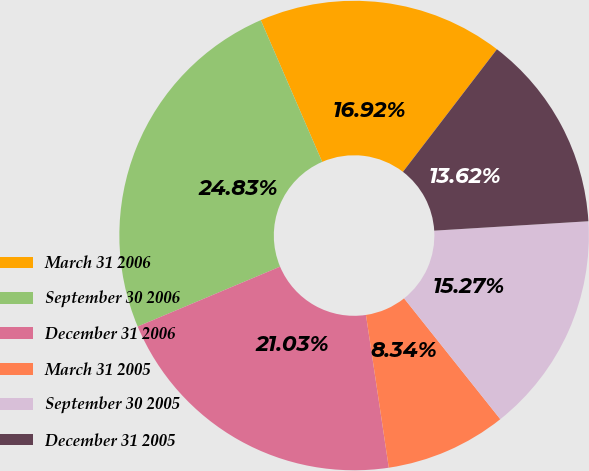Convert chart to OTSL. <chart><loc_0><loc_0><loc_500><loc_500><pie_chart><fcel>March 31 2006<fcel>September 30 2006<fcel>December 31 2006<fcel>March 31 2005<fcel>September 30 2005<fcel>December 31 2005<nl><fcel>16.92%<fcel>24.83%<fcel>21.03%<fcel>8.34%<fcel>15.27%<fcel>13.62%<nl></chart> 